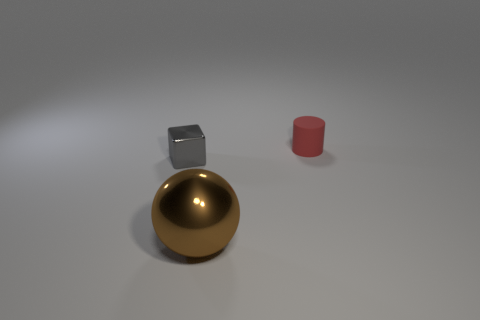Are there any other things that have the same material as the tiny red object?
Ensure brevity in your answer.  No. How many other objects are there of the same material as the small red cylinder?
Make the answer very short. 0. There is a thing in front of the small metallic block; what size is it?
Your answer should be very brief. Large. There is a brown object that is made of the same material as the tiny gray block; what is its shape?
Give a very brief answer. Sphere. Do the cube and the thing that is right of the big metallic thing have the same material?
Your answer should be very brief. No. Does the tiny thing to the right of the gray object have the same shape as the brown object?
Make the answer very short. No. Does the gray metallic object have the same shape as the thing that is in front of the block?
Offer a terse response. No. What color is the thing that is behind the metallic sphere and on the right side of the tiny gray object?
Make the answer very short. Red. Are there any metallic spheres?
Your answer should be very brief. Yes. Is the number of brown things in front of the brown object the same as the number of large things?
Offer a very short reply. No. 